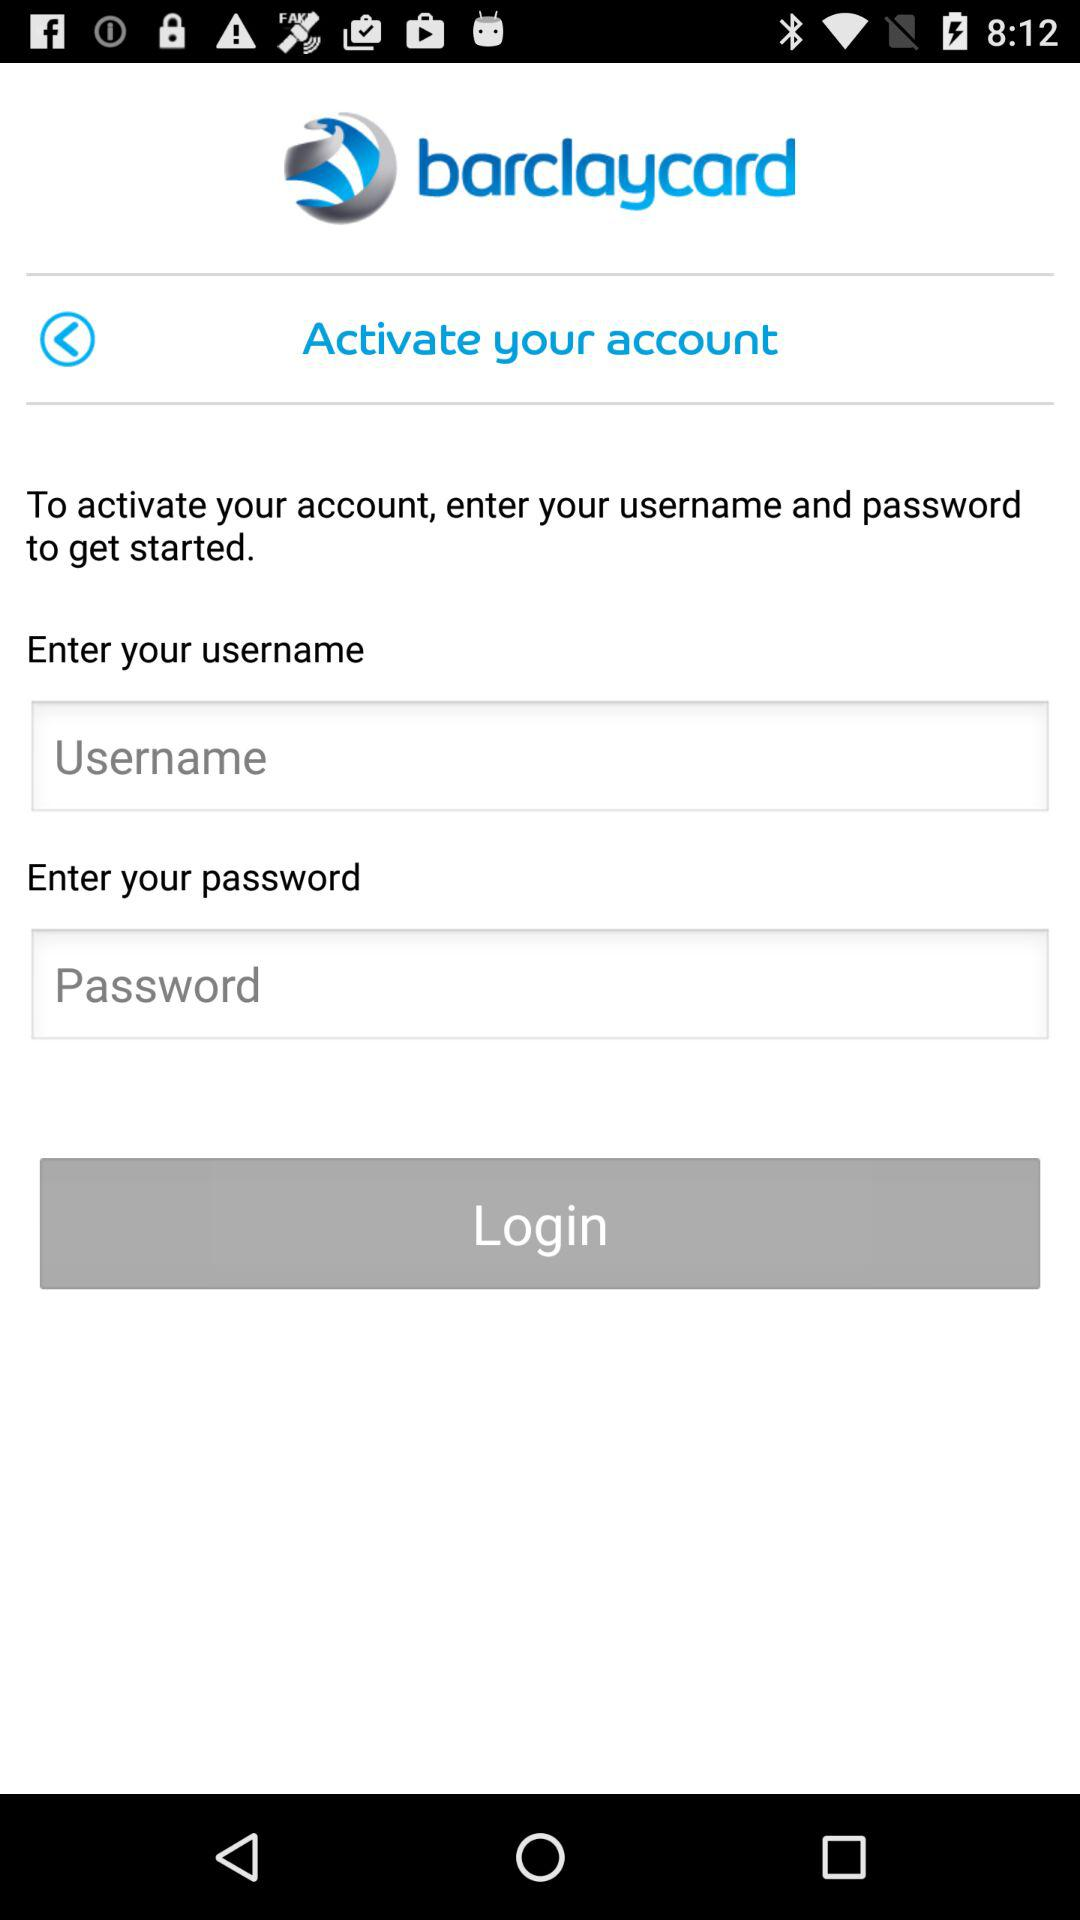What is the application name? The application name is "barclaycard". 